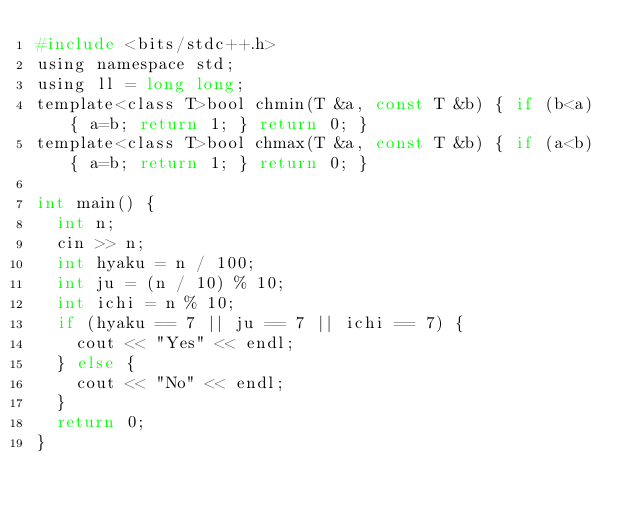<code> <loc_0><loc_0><loc_500><loc_500><_C_>#include <bits/stdc++.h>                                                                             
using namespace std;                                                                                 
using ll = long long;                                                                                
template<class T>bool chmin(T &a, const T &b) { if (b<a) { a=b; return 1; } return 0; }              
template<class T>bool chmax(T &a, const T &b) { if (a<b) { a=b; return 1; } return 0; }              
                                                                                                     
int main() {                                                                                         
  int n;                                                                                             
  cin >> n;                                                                                          
  int hyaku = n / 100;                                                                               
  int ju = (n / 10) % 10;                                                                            
  int ichi = n % 10;                                                                                 
  if (hyaku == 7 || ju == 7 || ichi == 7) {                                                          
    cout << "Yes" << endl;                                                                           
  } else {                                                                                           
    cout << "No" << endl;                                                                            
  }                                                                                                  
  return 0;                                                                                          
}                     </code> 